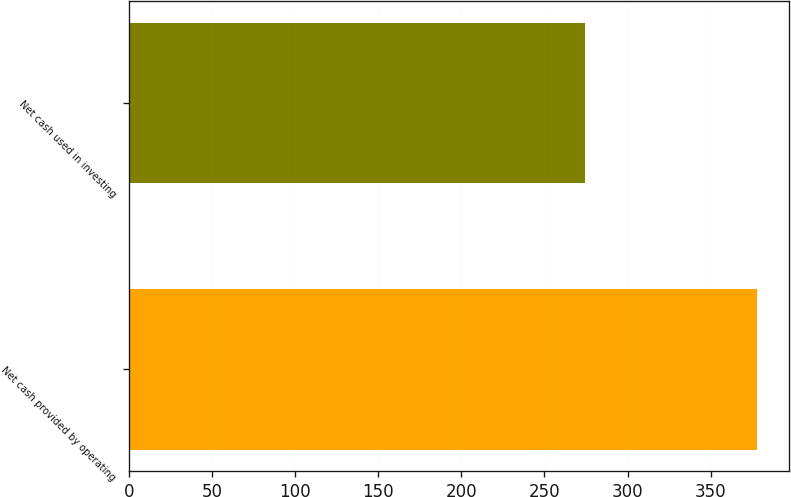<chart> <loc_0><loc_0><loc_500><loc_500><bar_chart><fcel>Net cash provided by operating<fcel>Net cash used in investing<nl><fcel>378.1<fcel>274.1<nl></chart> 